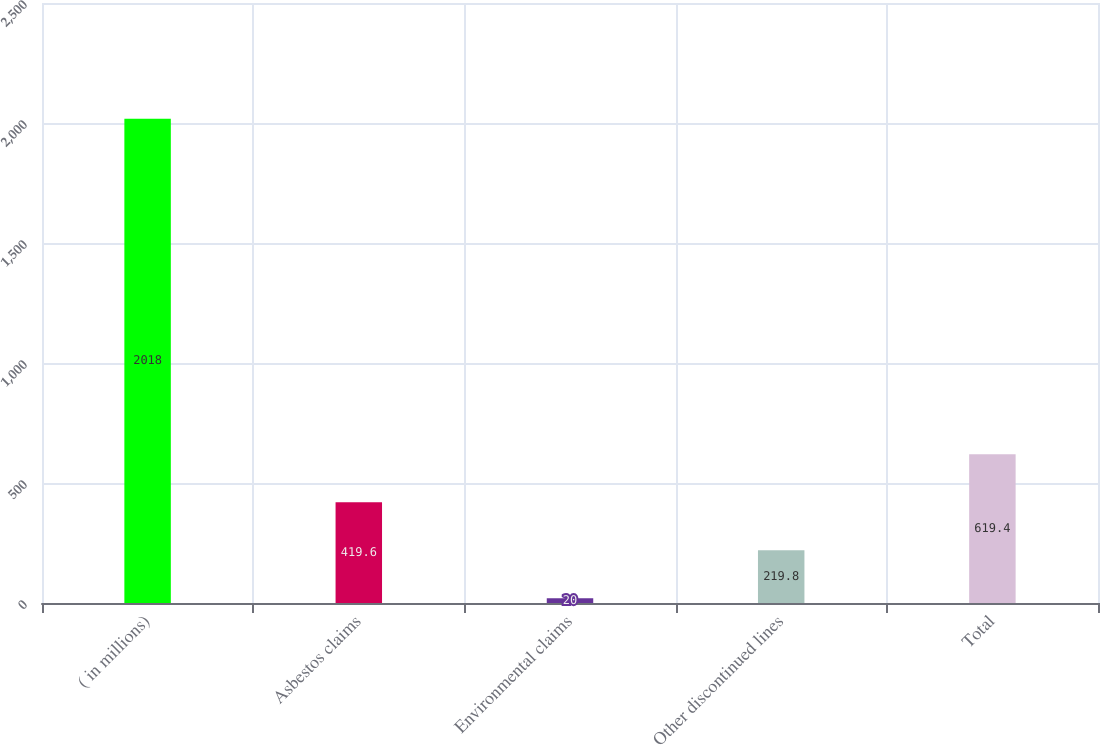<chart> <loc_0><loc_0><loc_500><loc_500><bar_chart><fcel>( in millions)<fcel>Asbestos claims<fcel>Environmental claims<fcel>Other discontinued lines<fcel>Total<nl><fcel>2018<fcel>419.6<fcel>20<fcel>219.8<fcel>619.4<nl></chart> 